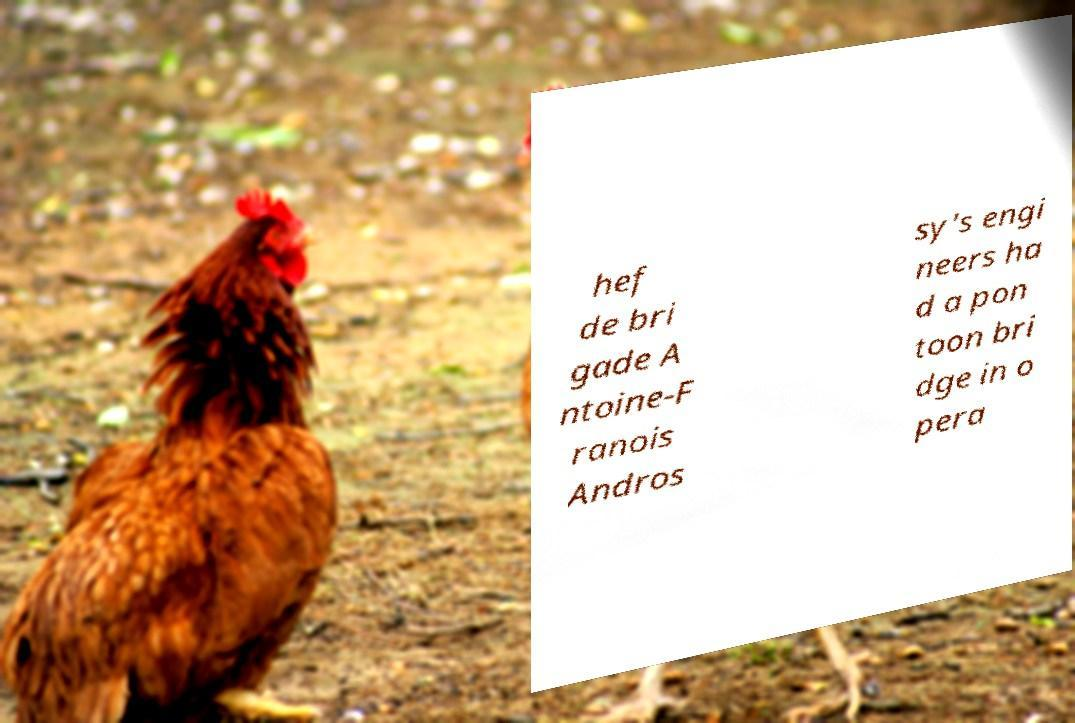Could you assist in decoding the text presented in this image and type it out clearly? hef de bri gade A ntoine-F ranois Andros sy's engi neers ha d a pon toon bri dge in o pera 